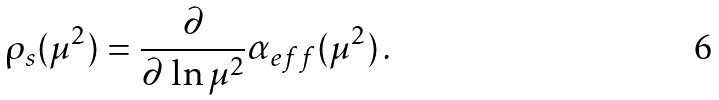Convert formula to latex. <formula><loc_0><loc_0><loc_500><loc_500>\rho _ { s } ( \mu ^ { 2 } ) = { \frac { \partial } { \partial \, \ln \mu ^ { 2 } } } \alpha _ { e f f } ( \mu ^ { 2 } ) \, .</formula> 